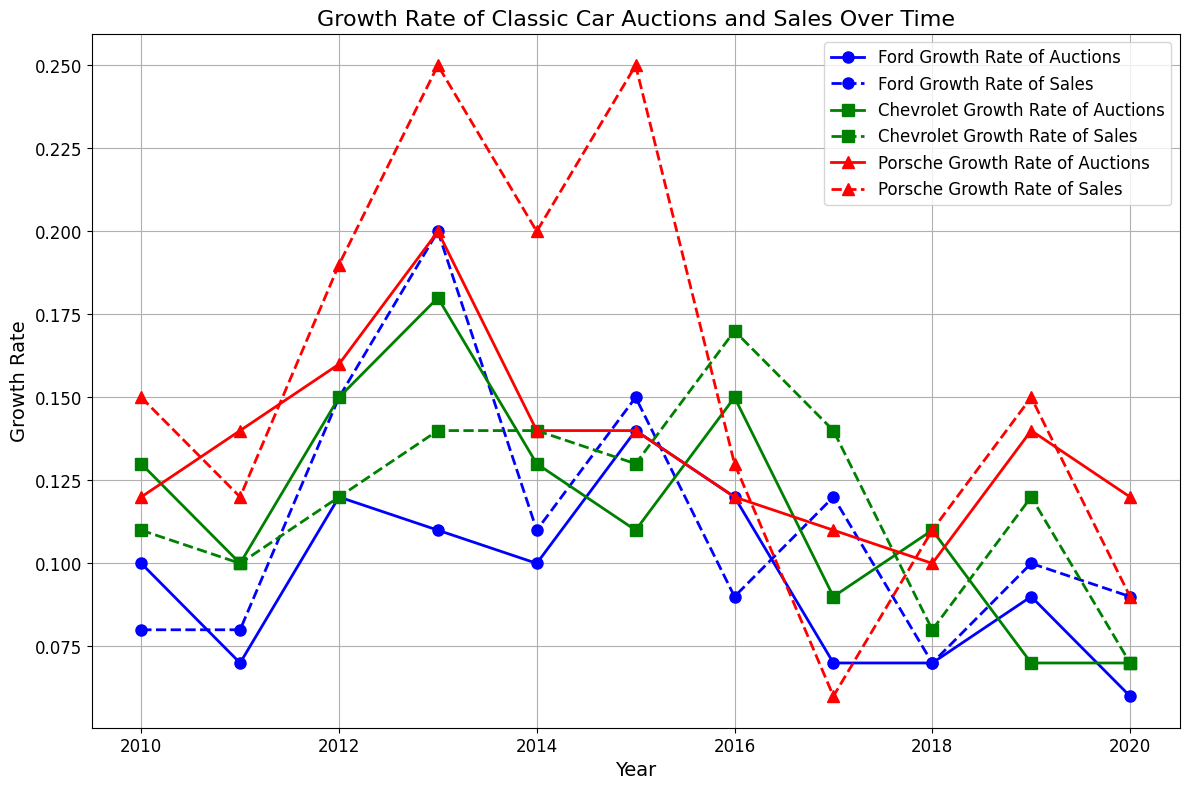Which brand has the highest growth rate of auctions in 2012? To determine this, find the 2012 data for all brands and compare their growth rates of auctions. For Ford, it is 0.12, for Chevrolet 0.15, and for Porsche 0.16. Porsche has the highest growth rate of auctions in 2012.
Answer: Porsche In which year did Ford have the highest growth rate of sales? Identify Ford's data and locate the year with the highest growth rate. Ford's growth rates of sales are 0.08 (2010), 0.08 (2011), 0.15 (2012), 0.20 (2013), 0.11 (2014), 0.15 (2015), 0.09 (2016), 0.12 (2017), 0.07 (2018), 0.10 (2019), and 0.09 (2020). The highest value is 0.20 in 2013.
Answer: 2013 Compare the growth rates of auctions between Ford and Chevrolet in 2015. Which one is greater? Check the data for 2015 for both brands: Ford's growth rate of auctions in 2015 is 0.14 and Chevrolet's is 0.11. Therefore, Ford's growth rate is greater.
Answer: Ford What was the trend for Porsche’s growth rate of sales between 2012 and 2015? Extract Porsche's data for the growth rate of sales between 2012 and 2015: 0.19 (2012), 0.25 (2013), 0.20 (2014), and 0.25 (2015). The trend involves an increase from 0.19 to 0.25, a slight drop to 0.20, and then back up to 0.25.
Answer: Increasing, then fluctuating Among all the brands, which one had the least consistent growth rate of sales over the decade? Evaluate the variability in the growth rates of sales for each brand. Porsche has high fluctuations with values ranging from 0.15 to 0.25, suggesting it had the least consistent growth rate of sales.
Answer: Porsche Which year saw the lowest growth rate of auctions for all brands combined? Check the minimum growth rate of auctions for each brand by year. For Ford, it is 0.06 in 2020; for Chevrolet, it is 0.07 in 2018 and 2020; for Porsche, it is 0.10 in 2018. The lowest among these is Ford's 0.06 in 2020.
Answer: 2020 What is the average growth rate of auctions for all brands in 2018? Calculate the sum of the growth rates of auctions in 2018 for Ford (0.07), Chevrolet (0.11), and Porsche (0.10), which equals 0.28. Then divide by the number of brands, which is 3, resulting in an average of 0.0933.
Answer: 0.0933 How did the growth rates of sales for Ford and Chevrolet compare in 2016? Retrieve 2016 values for Ford (0.09) and Chevrolet (0.17) and compare them. Chevrolet's growth rate of sales is higher (0.17 compared to Ford's 0.09).
Answer: Chevrolet Which brand had a constant growth rate of auctions for two consecutive years at any time? Examine the growth rates of auctions for steady consecutive values. Ford shows constant growth rates of auctions of 0.07 in both 2011 and 2012, and again in 2018 and 2019.
Answer: Ford 